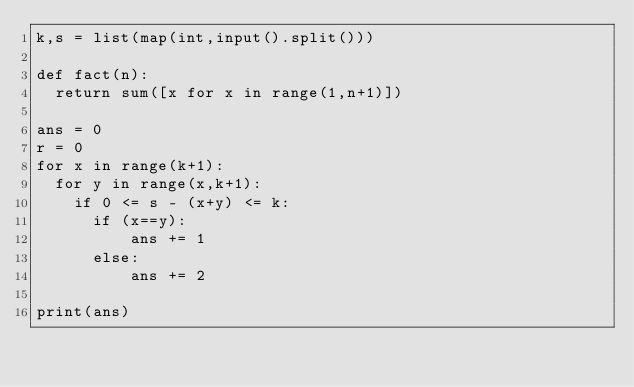Convert code to text. <code><loc_0><loc_0><loc_500><loc_500><_Python_>k,s = list(map(int,input().split()))

def fact(n):
  return sum([x for x in range(1,n+1)])

ans = 0
r = 0
for x in range(k+1):
  for y in range(x,k+1):
    if 0 <= s - (x+y) <= k:
      if (x==y):
          ans += 1
      else:
          ans += 2

print(ans)</code> 